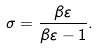<formula> <loc_0><loc_0><loc_500><loc_500>\sigma = \frac { \beta \varepsilon } { \beta \varepsilon - 1 } .</formula> 